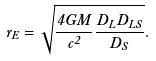<formula> <loc_0><loc_0><loc_500><loc_500>r _ { E } = \sqrt { \frac { 4 G M } { c ^ { 2 } } \frac { D _ { L } D _ { L S } } { D _ { S } } } .</formula> 